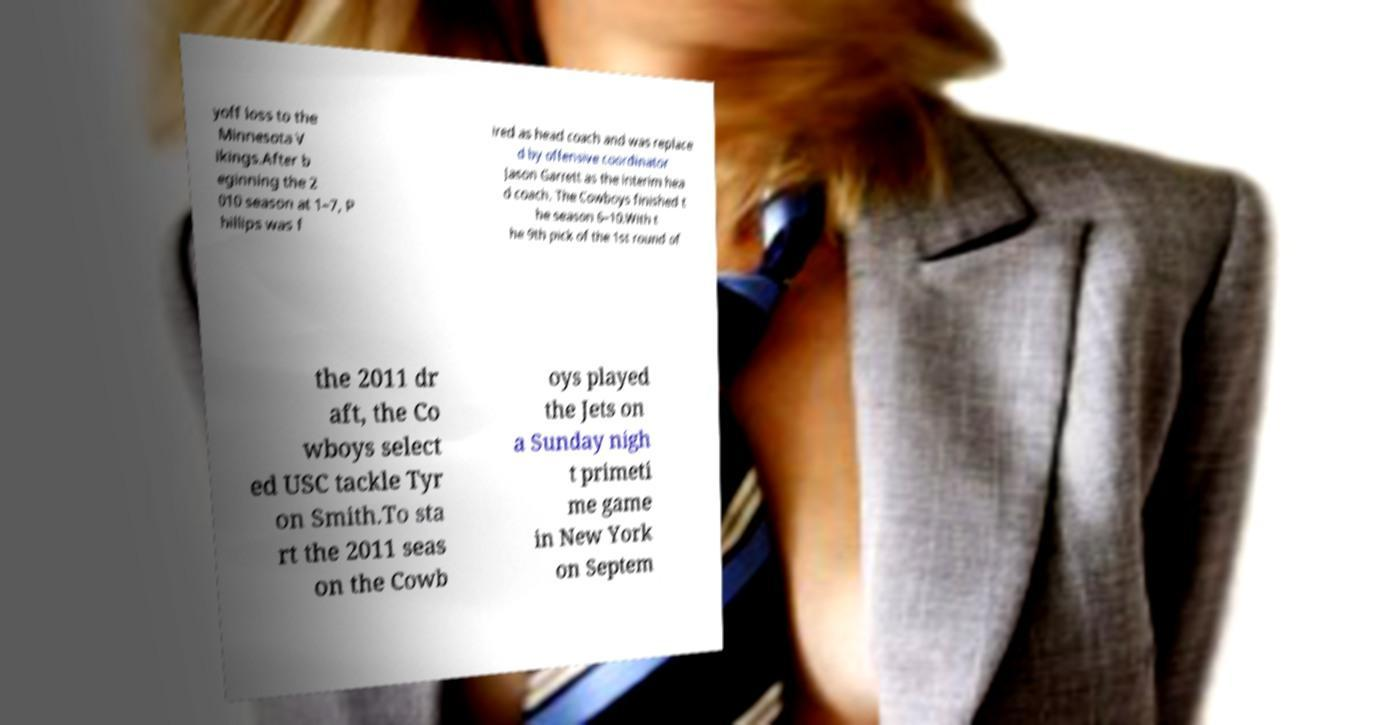Please read and relay the text visible in this image. What does it say? yoff loss to the Minnesota V ikings.After b eginning the 2 010 season at 1–7, P hillips was f ired as head coach and was replace d by offensive coordinator Jason Garrett as the interim hea d coach. The Cowboys finished t he season 6–10.With t he 9th pick of the 1st round of the 2011 dr aft, the Co wboys select ed USC tackle Tyr on Smith.To sta rt the 2011 seas on the Cowb oys played the Jets on a Sunday nigh t primeti me game in New York on Septem 